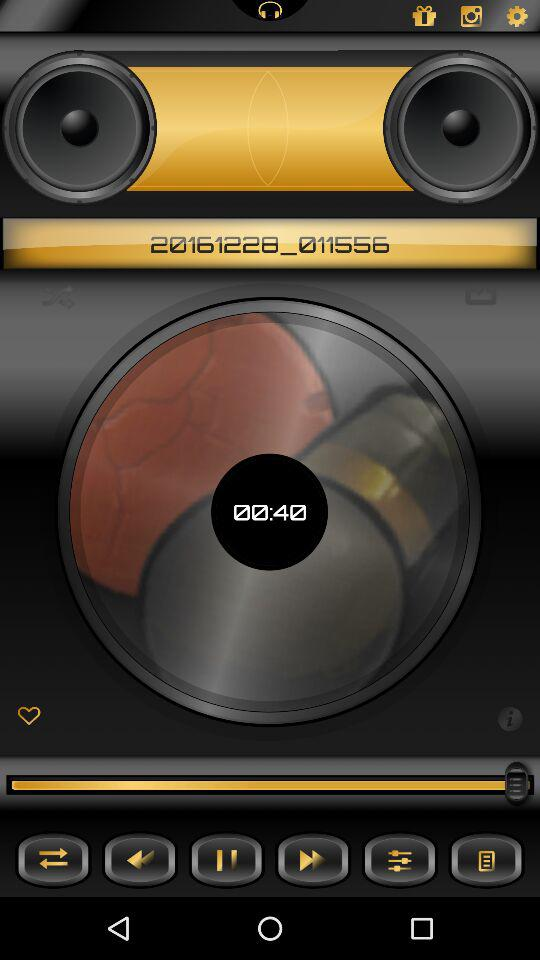What is the time duration? The time duration is 00:40. 